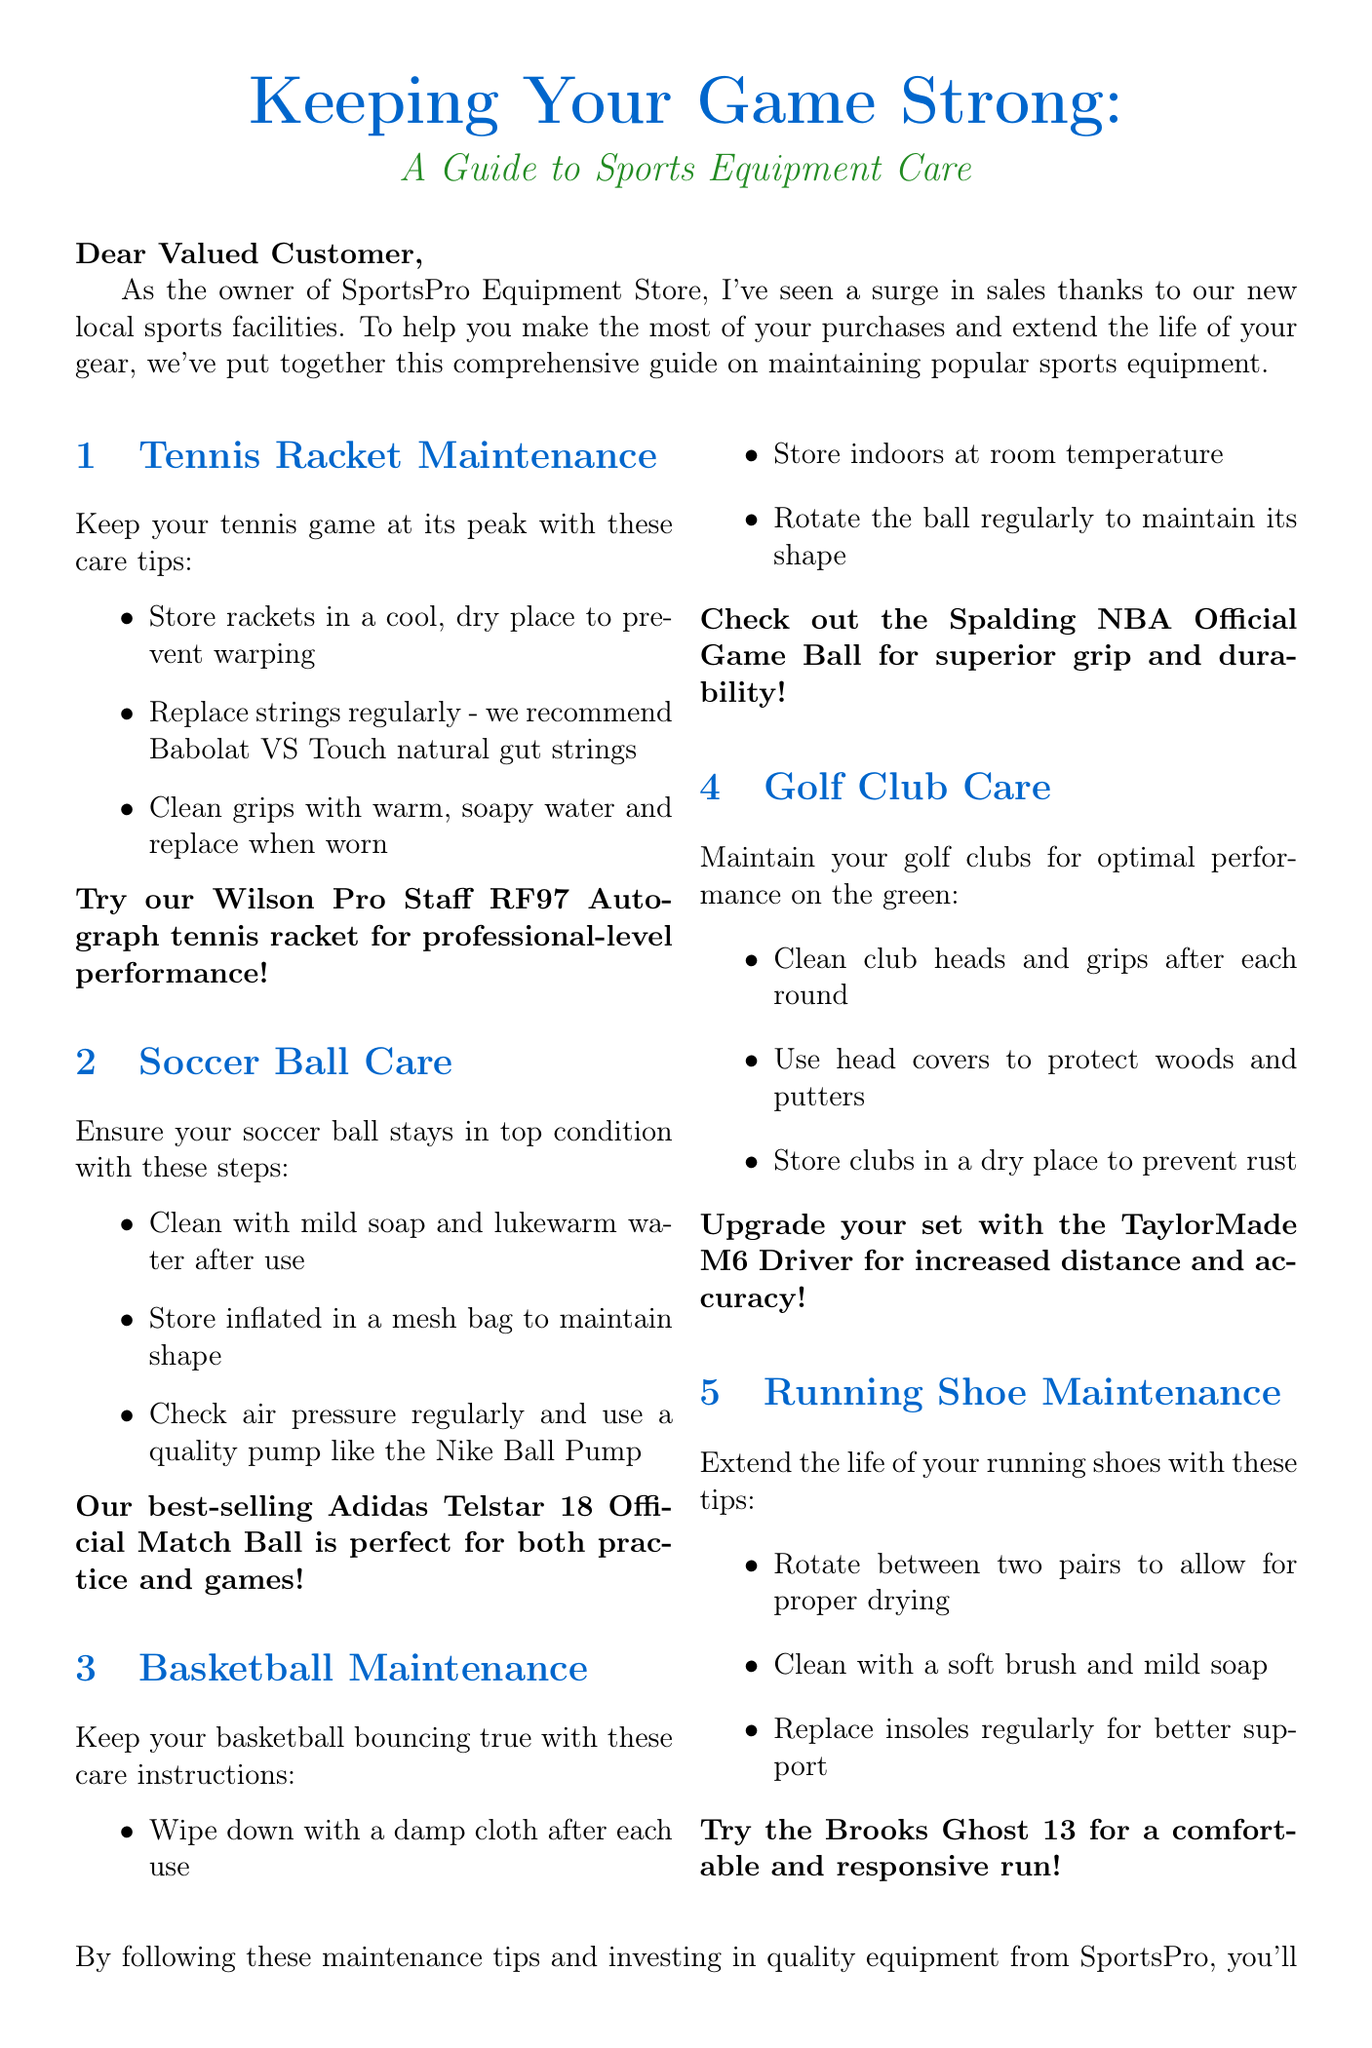What is the title of the newsletter? The title of the newsletter is presented at the beginning of the document.
Answer: Keeping Your Game Strong: A Guide to Sports Equipment Care What product is recommended for tennis racket maintenance? The document specifies a particular product to use for tennis racket maintenance in the tips.
Answer: Wilson Pro Staff RF97 Autograph tennis racket How should a soccer ball be stored? The care section for soccer balls outlines storage recommendations, including methods to keep the ball in shape.
Answer: Inflated in a mesh bag What is a recommended pump for checking soccer ball air pressure? The recommendations include a specific product for maintaining air pressure in soccer balls.
Answer: Nike Ball Pump How often should running shoe insoles be replaced? The maintenance tips for running shoes suggest a certain practice for better support.
Answer: Regularly Which basketball provides superior grip and durability? The document explicitly mentions a product that is noted for its grip and durability in basketball maintenance.
Answer: Spalding NBA Official Game Ball What special discount is offered in the newsletter? The newsletter concludes with a promotional offer that details the discount available for readers.
Answer: 10% discount What is advised for golf club storage? The golf club care section includes specific instructions regarding storage to avoid damage.
Answer: In a dry place Which tennis strings are recommended in the newsletter? The tips section for tennis rackets identifies a specific brand and type of strings to use.
Answer: Babolat VS Touch natural gut strings 